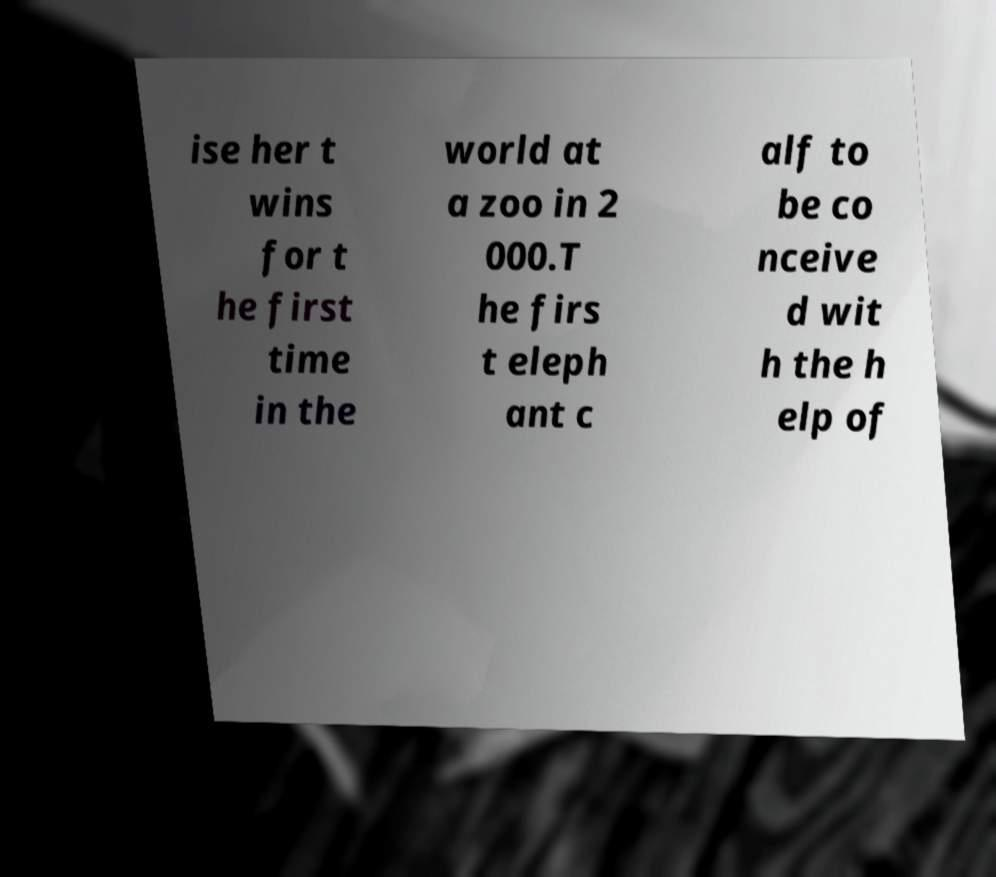Can you read and provide the text displayed in the image?This photo seems to have some interesting text. Can you extract and type it out for me? ise her t wins for t he first time in the world at a zoo in 2 000.T he firs t eleph ant c alf to be co nceive d wit h the h elp of 